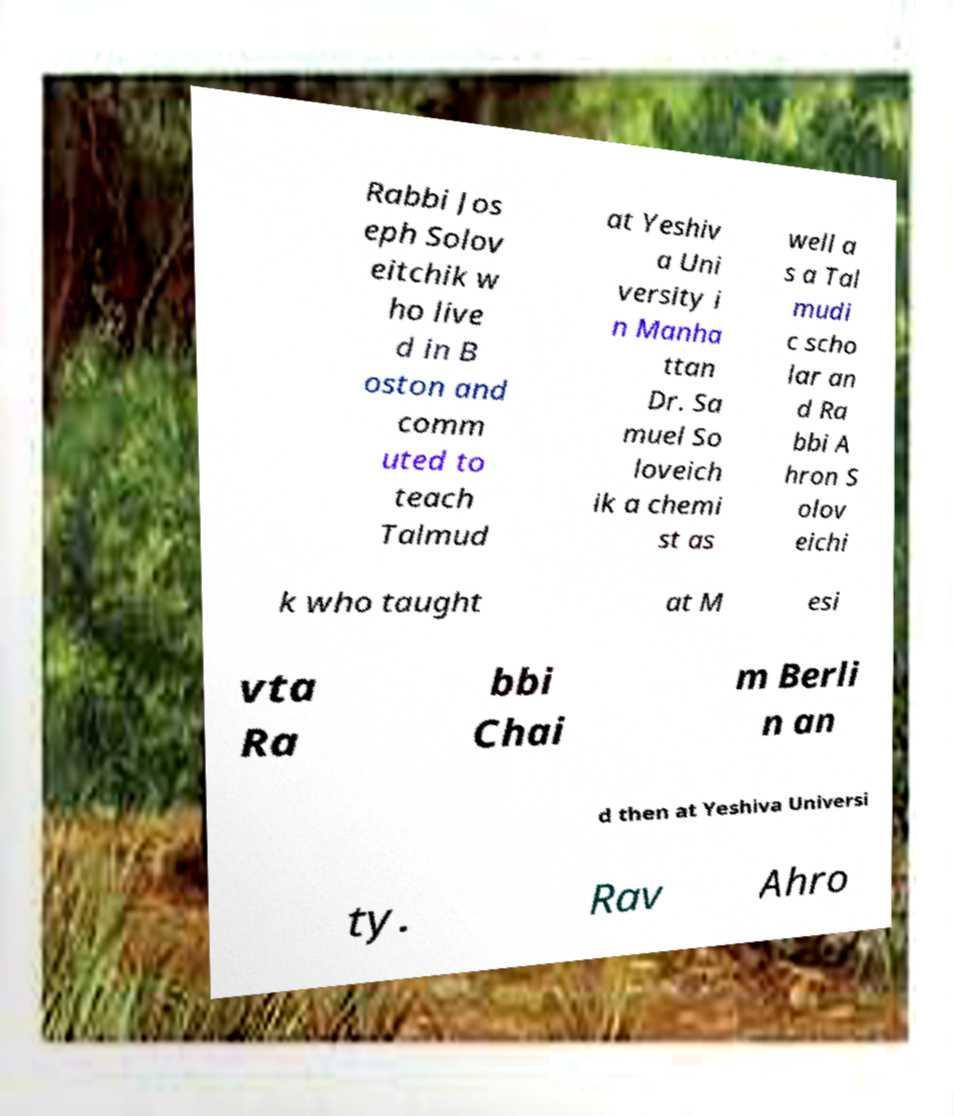Can you accurately transcribe the text from the provided image for me? Rabbi Jos eph Solov eitchik w ho live d in B oston and comm uted to teach Talmud at Yeshiv a Uni versity i n Manha ttan Dr. Sa muel So loveich ik a chemi st as well a s a Tal mudi c scho lar an d Ra bbi A hron S olov eichi k who taught at M esi vta Ra bbi Chai m Berli n an d then at Yeshiva Universi ty. Rav Ahro 